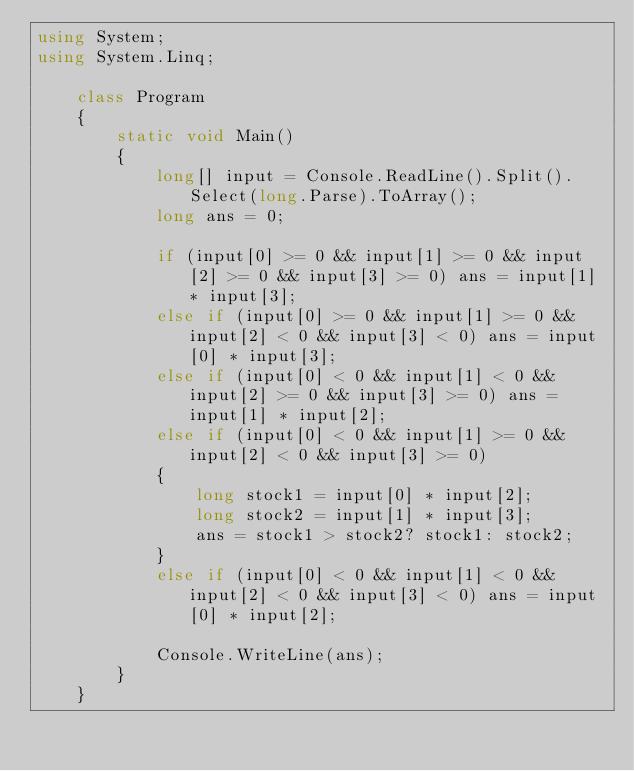<code> <loc_0><loc_0><loc_500><loc_500><_C#_>using System;
using System.Linq;

    class Program
    {
        static void Main()
        {
            long[] input = Console.ReadLine().Split().Select(long.Parse).ToArray();
            long ans = 0;

            if (input[0] >= 0 && input[1] >= 0 && input[2] >= 0 && input[3] >= 0) ans = input[1] * input[3];
            else if (input[0] >= 0 && input[1] >= 0 && input[2] < 0 && input[3] < 0) ans = input[0] * input[3];
            else if (input[0] < 0 && input[1] < 0 && input[2] >= 0 && input[3] >= 0) ans = input[1] * input[2];
            else if (input[0] < 0 && input[1] >= 0 && input[2] < 0 && input[3] >= 0)
            {
                long stock1 = input[0] * input[2];
                long stock2 = input[1] * input[3];
                ans = stock1 > stock2? stock1: stock2;
            }
            else if (input[0] < 0 && input[1] < 0 && input[2] < 0 && input[3] < 0) ans = input[0] * input[2];

            Console.WriteLine(ans);
        }
    }</code> 